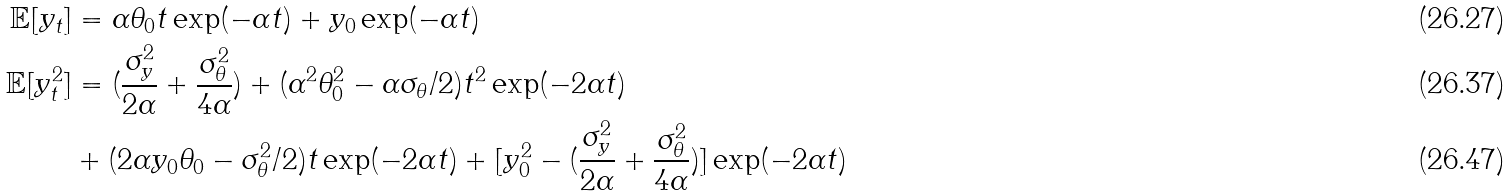Convert formula to latex. <formula><loc_0><loc_0><loc_500><loc_500>\mathbb { E } [ y _ { t } ] & = \alpha \theta _ { 0 } t \exp ( - \alpha t ) + y _ { 0 } \exp ( - \alpha t ) \\ \mathbb { E } [ y _ { t } ^ { 2 } ] & = ( \frac { \sigma _ { y } ^ { 2 } } { 2 \alpha } + \frac { \sigma _ { \theta } ^ { 2 } } { 4 \alpha } ) + ( \alpha ^ { 2 } \theta _ { 0 } ^ { 2 } - \alpha \sigma _ { \theta } / 2 ) t ^ { 2 } \exp ( - 2 \alpha t ) \\ & + ( 2 \alpha y _ { 0 } \theta _ { 0 } - \sigma _ { \theta } ^ { 2 } / 2 ) t \exp ( - 2 \alpha t ) + [ y _ { 0 } ^ { 2 } - ( \frac { \sigma _ { y } ^ { 2 } } { 2 \alpha } + \frac { \sigma _ { \theta } ^ { 2 } } { 4 \alpha } ) ] \exp ( - 2 \alpha t )</formula> 